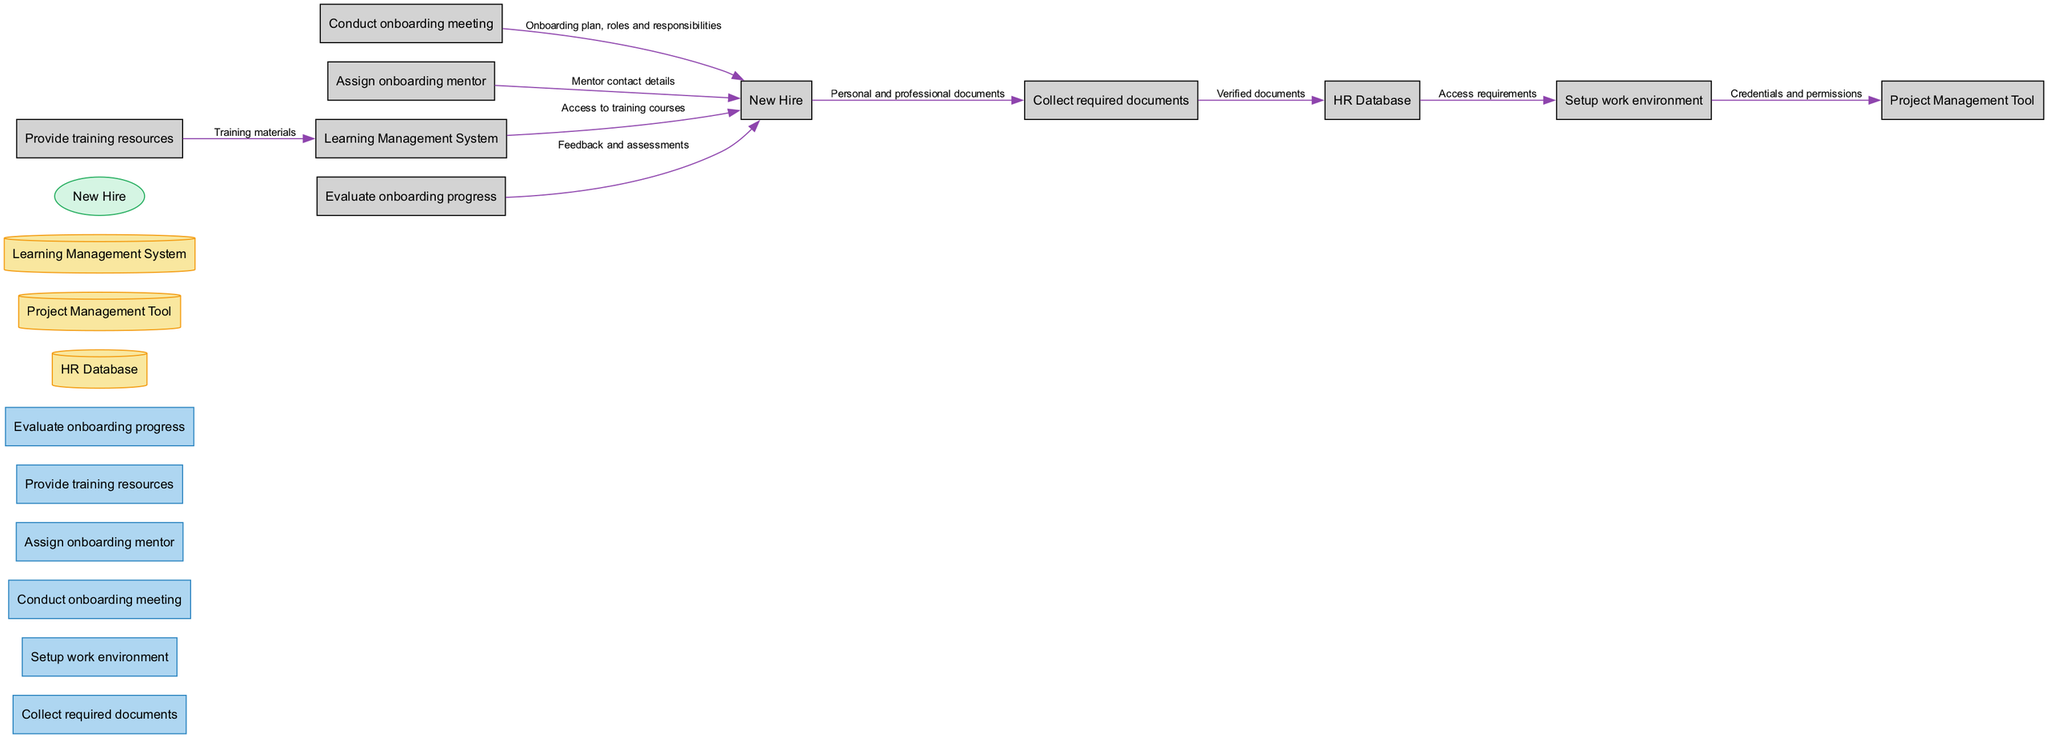What is the total number of processes in the diagram? The diagram lists six distinct processes: Collect required documents, Setup work environment, Conduct onboarding meeting, Assign onboarding mentor, Provide training resources, and Evaluate onboarding progress. Counting these processes gives a total of six.
Answer: six What is the name of the data store that holds information about new hires and their documents? According to the diagram, the data store that captures information related to new hires and their documents is labeled as "HR Database."
Answer: HR Database What type of document does the new hire provide in the onboarding process? The diagram indicates that the new hire provides "Personal and professional documents" during the document collection stage.
Answer: Personal and professional documents Which process follows the "Conduct onboarding meeting"? Following the "Conduct onboarding meeting," the next identified process in the diagram is "Assign onboarding mentor." This illustrates the flow of operations in the onboarding sequence.
Answer: Assign onboarding mentor Identify the flow from "Learning Management System" to "New Hire." The flow from "Learning Management System" to "New Hire" is labeled as "Access to training courses." This provides the new hire with essential training resources.
Answer: Access to training courses What is the relationship between the "Setup work environment" process and the "Project Management Tool"? The "Setup work environment" process transfers "Credentials and permissions" to the "Project Management Tool," indicating that this process is responsible for configuring tools necessary for the new hire's tasks.
Answer: Credentials and permissions Which process is primarily responsible for assessing the onboarding process? The process responsible for evaluating the onboarding process is labeled "Evaluate onboarding progress." This process involves feedback and assessments concerning the new hire's progress.
Answer: Evaluate onboarding progress How many external entities are depicted in the diagram? The diagram includes one external entity, which is "New Hire." This represents the newly hired remote team member who engages in the onboarding process.
Answer: one What type of data flows from "Provide training resources" to "Learning Management System"? The flow from "Provide training resources" to "Learning Management System" is denoted as "Training materials," indicating that relevant training resources are stored within this system.
Answer: Training materials What is the purpose of the "Assign onboarding mentor" process? The purpose of the "Assign onboarding mentor" process is to designate an experienced team member to guide the new hire throughout the onboarding journey, ensuring they have the support needed.
Answer: Designate an experienced team member 